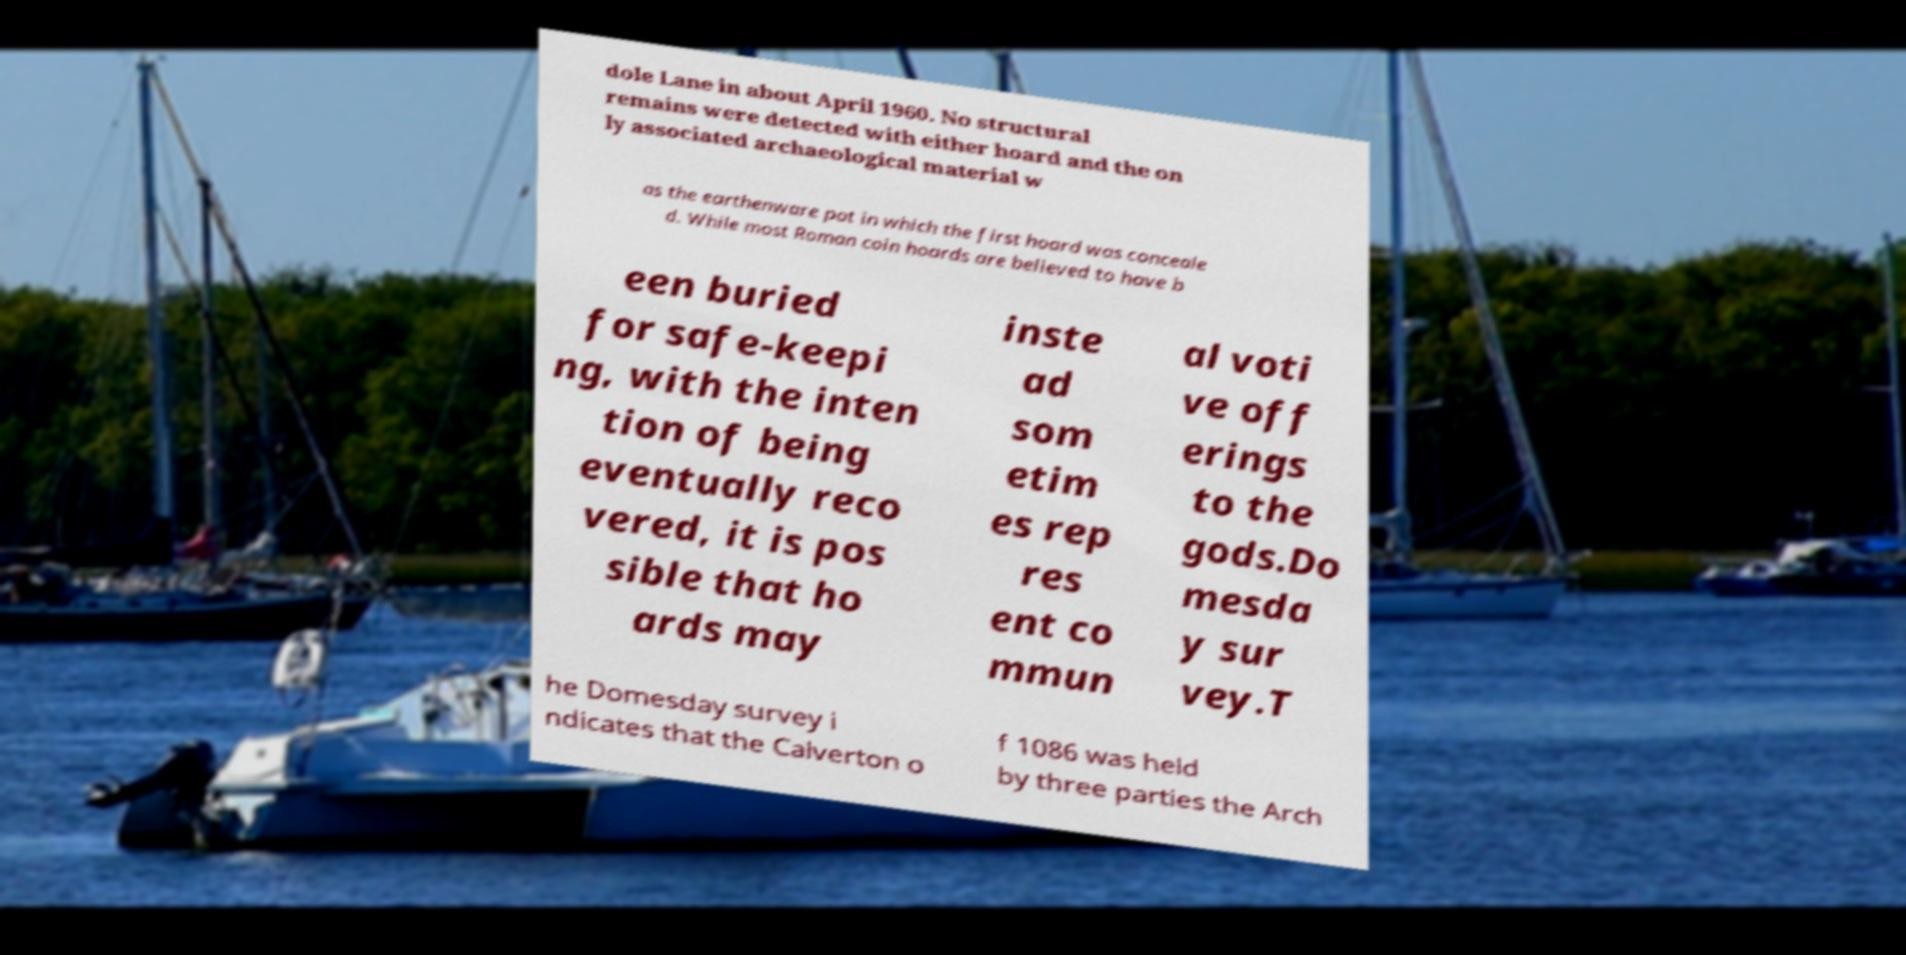I need the written content from this picture converted into text. Can you do that? dole Lane in about April 1960. No structural remains were detected with either hoard and the on ly associated archaeological material w as the earthenware pot in which the first hoard was conceale d. While most Roman coin hoards are believed to have b een buried for safe-keepi ng, with the inten tion of being eventually reco vered, it is pos sible that ho ards may inste ad som etim es rep res ent co mmun al voti ve off erings to the gods.Do mesda y sur vey.T he Domesday survey i ndicates that the Calverton o f 1086 was held by three parties the Arch 